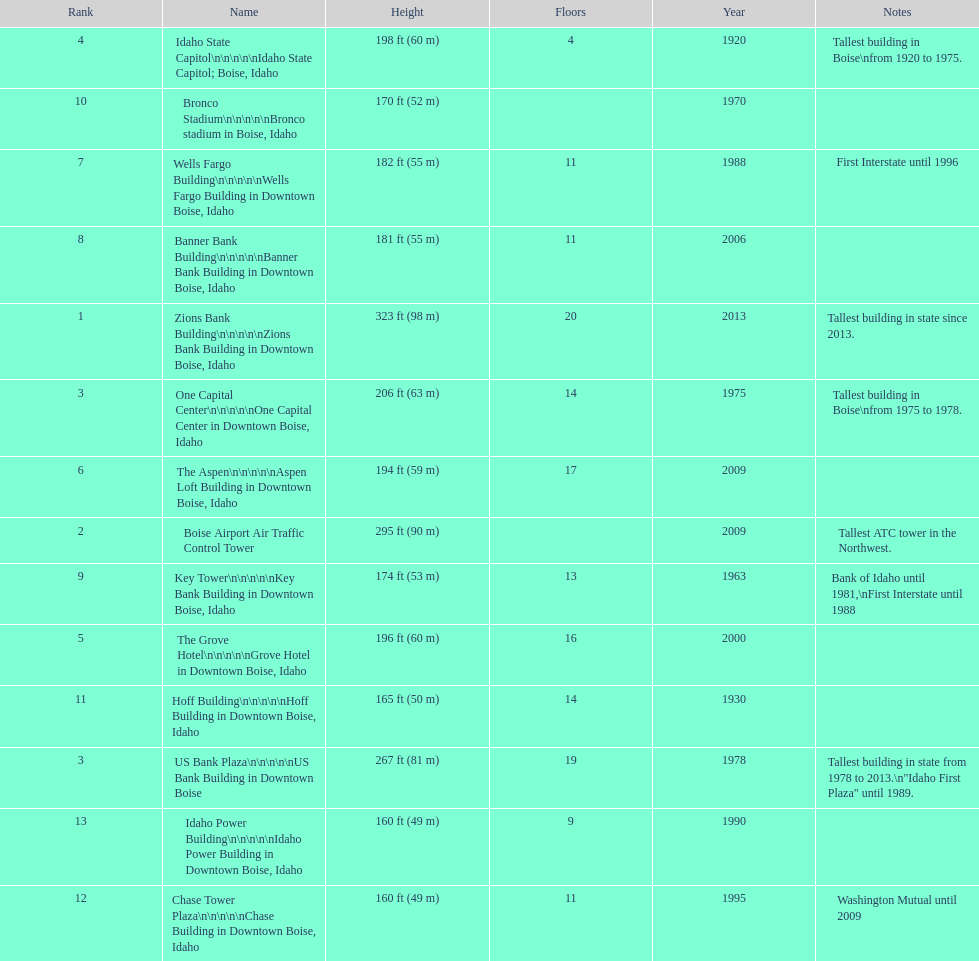What are the number of floors the us bank plaza has? 19. 